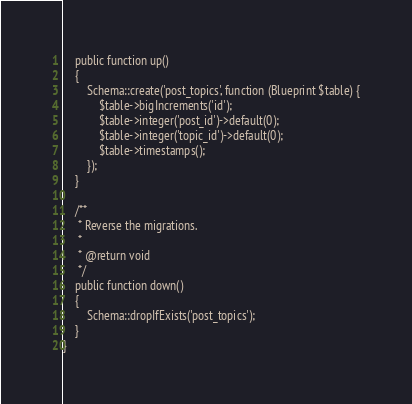Convert code to text. <code><loc_0><loc_0><loc_500><loc_500><_PHP_>    public function up()
    {
        Schema::create('post_topics', function (Blueprint $table) {
            $table->bigIncrements('id');
            $table->integer('post_id')->default(0);
            $table->integer('topic_id')->default(0);
            $table->timestamps();
        });
    }

    /**
     * Reverse the migrations.
     *
     * @return void
     */
    public function down()
    {
        Schema::dropIfExists('post_topics');
    }
}
</code> 